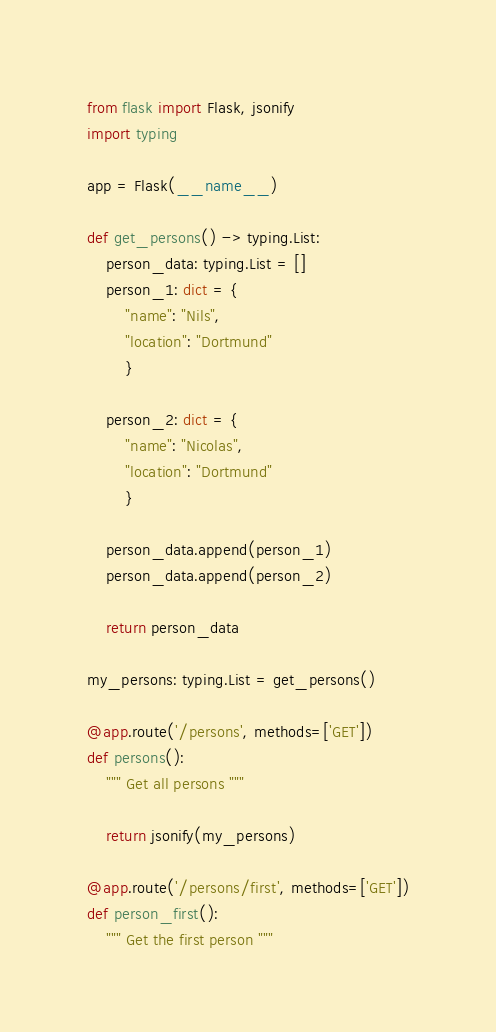<code> <loc_0><loc_0><loc_500><loc_500><_Python_>from flask import Flask, jsonify
import typing

app = Flask(__name__)

def get_persons() -> typing.List:
    person_data: typing.List = []
    person_1: dict = {
        "name": "Nils",
        "location": "Dortmund"
        }
    
    person_2: dict = {
        "name": "Nicolas",
        "location": "Dortmund"
        }
    
    person_data.append(person_1)
    person_data.append(person_2)
    
    return person_data

my_persons: typing.List = get_persons()

@app.route('/persons', methods=['GET'])
def persons():
    """ Get all persons """

    return jsonify(my_persons)

@app.route('/persons/first', methods=['GET'])
def person_first():
    """ Get the first person """</code> 